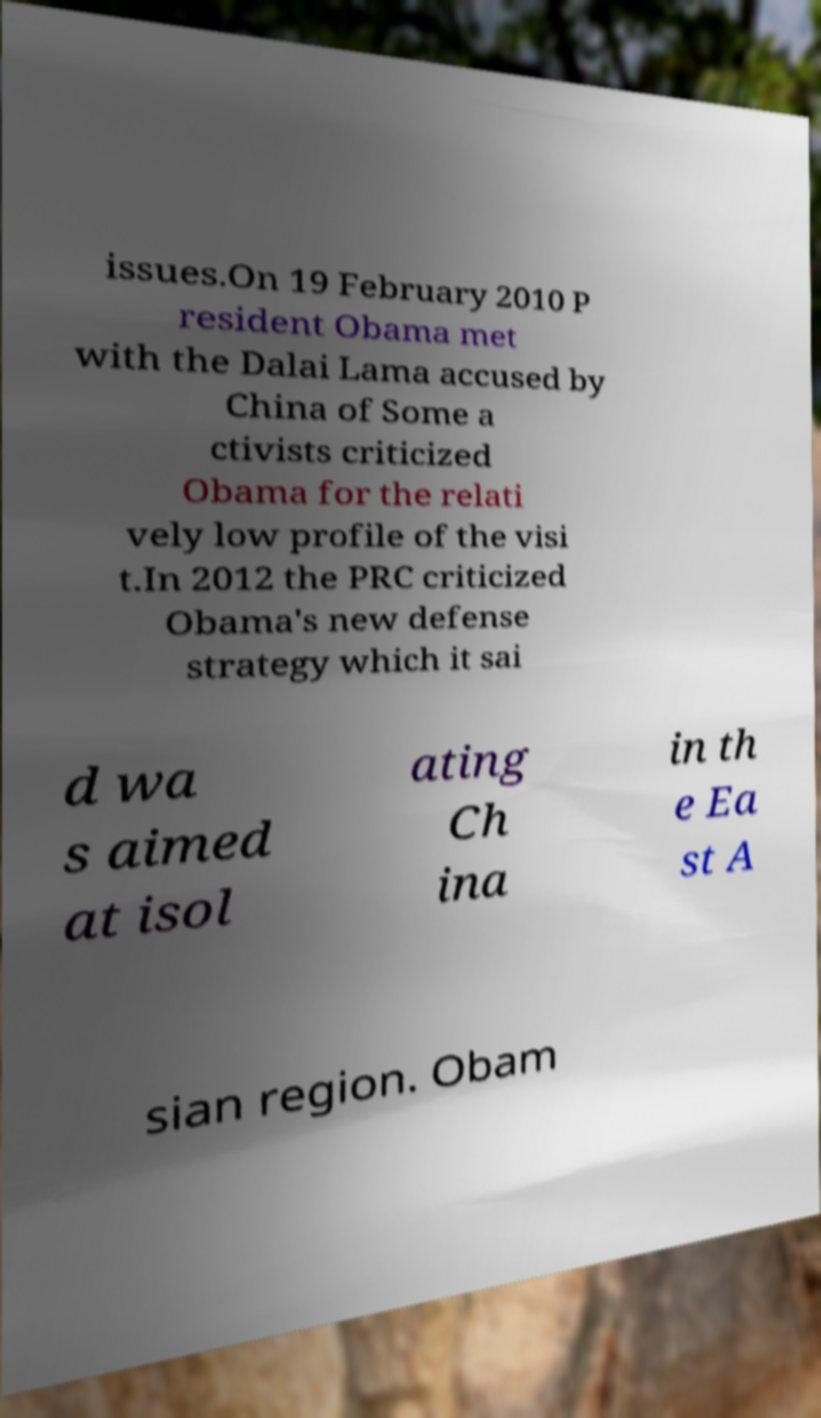For documentation purposes, I need the text within this image transcribed. Could you provide that? issues.On 19 February 2010 P resident Obama met with the Dalai Lama accused by China of Some a ctivists criticized Obama for the relati vely low profile of the visi t.In 2012 the PRC criticized Obama's new defense strategy which it sai d wa s aimed at isol ating Ch ina in th e Ea st A sian region. Obam 